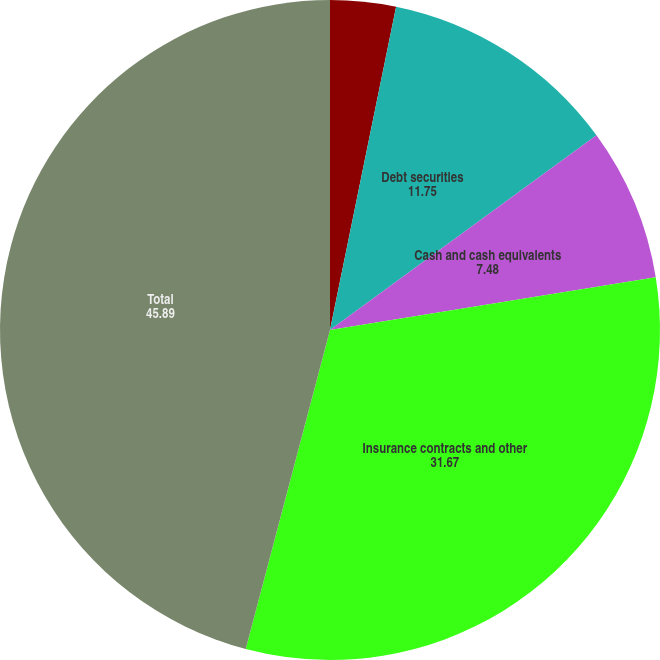Convert chart. <chart><loc_0><loc_0><loc_500><loc_500><pie_chart><fcel>Equity securities<fcel>Debt securities<fcel>Cash and cash equivalents<fcel>Insurance contracts and other<fcel>Total<nl><fcel>3.21%<fcel>11.75%<fcel>7.48%<fcel>31.67%<fcel>45.89%<nl></chart> 